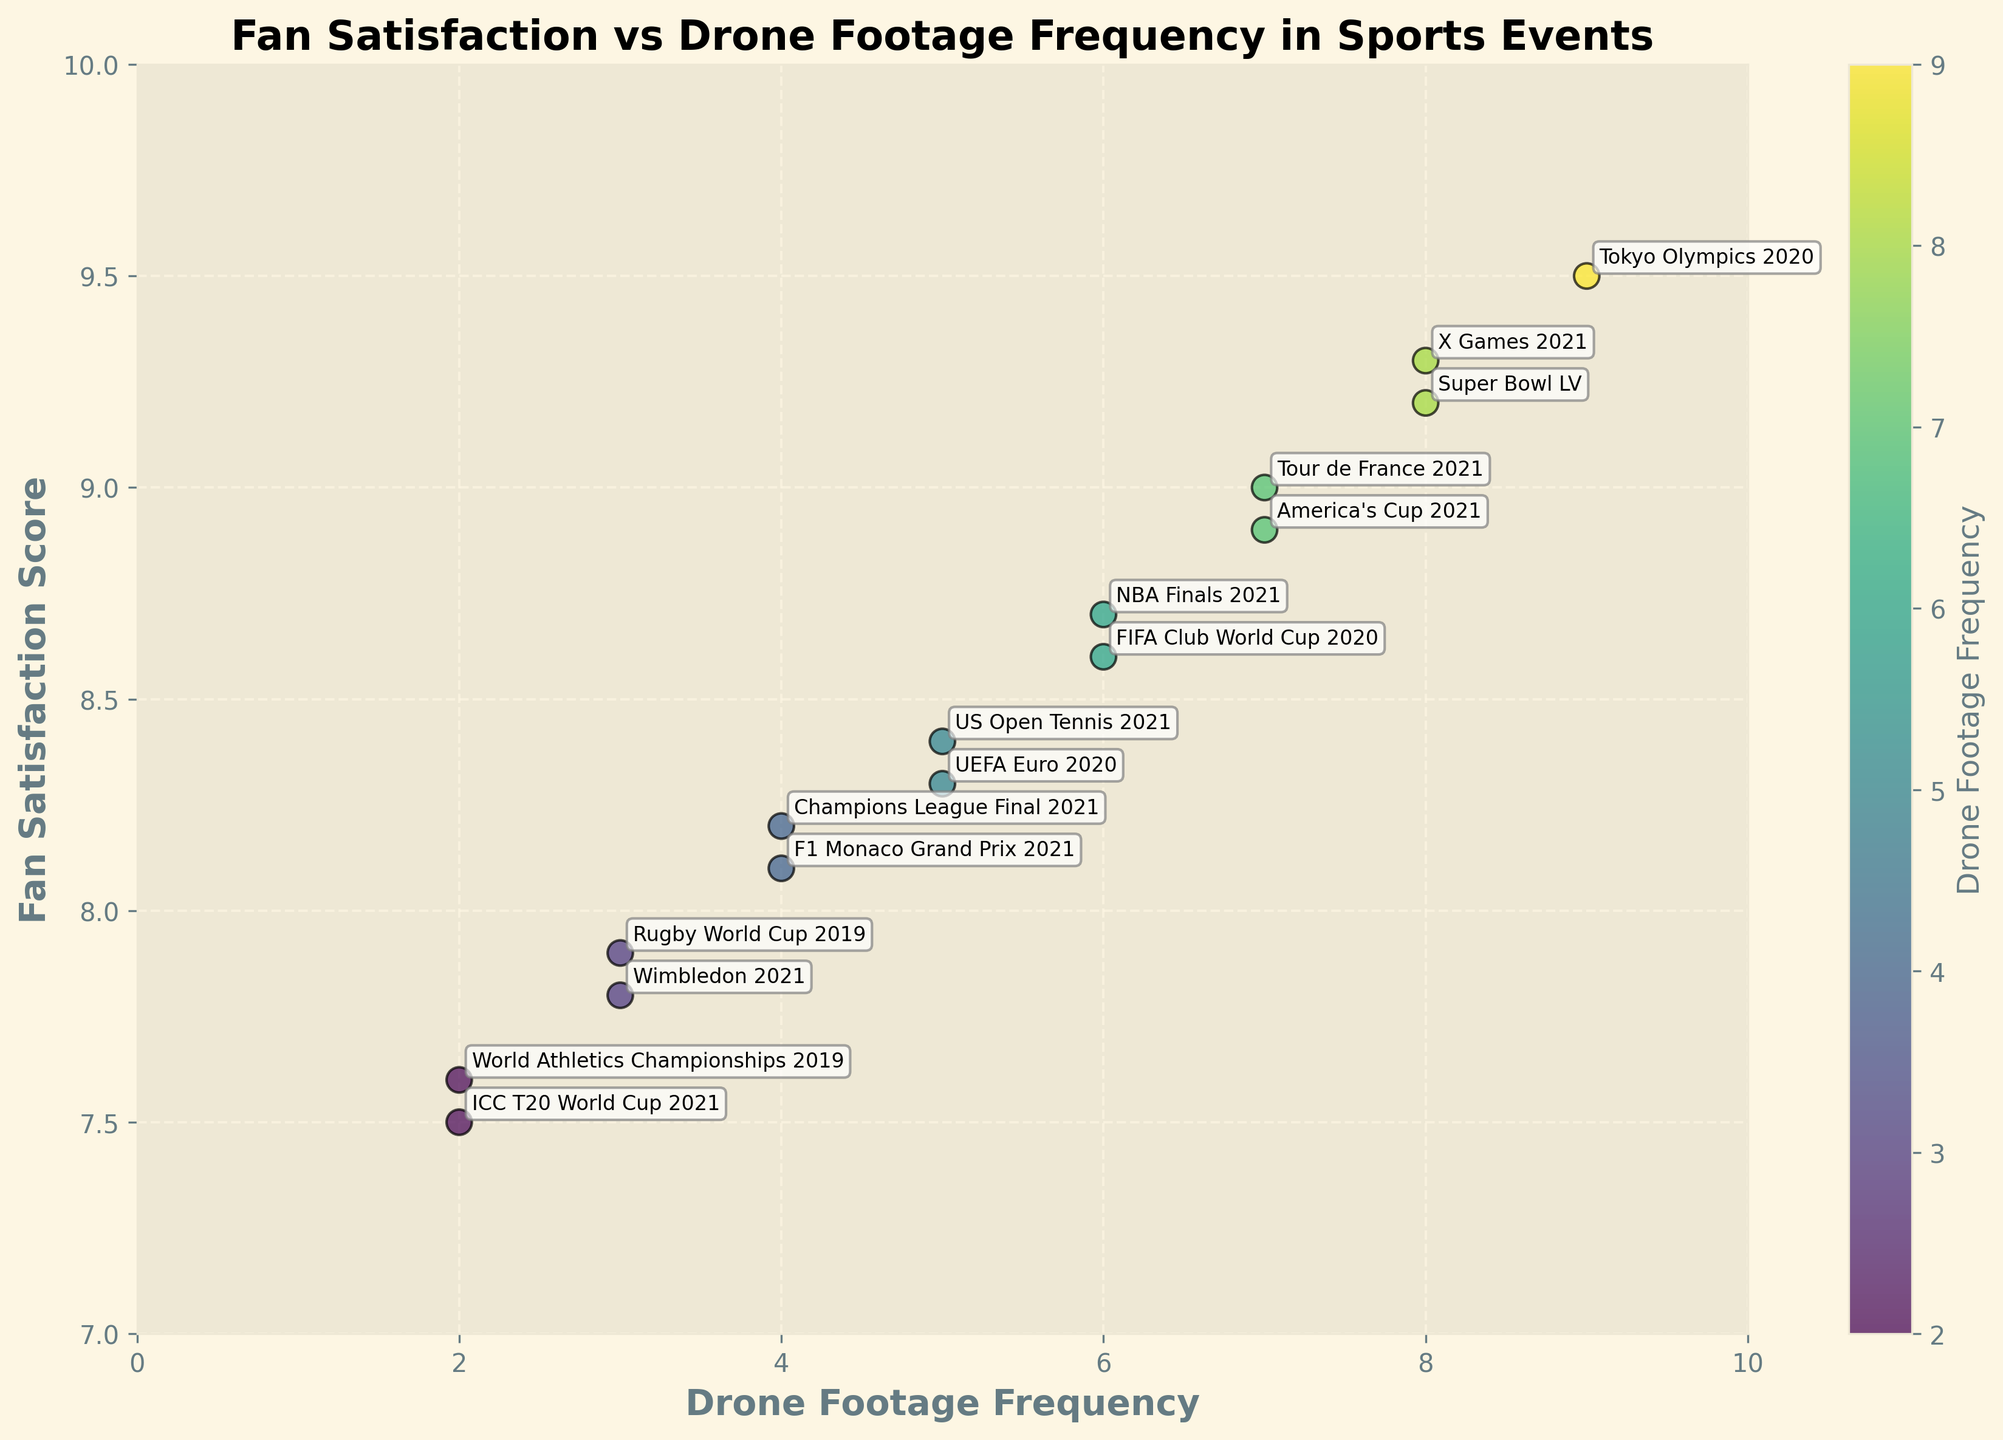What is the title of the figure? The title is typically located at the top of the figure. In this plot, the title indicates the relationship being analyzed.
Answer: Fan Satisfaction vs Drone Footage Frequency in Sports Events What are the x-axis and y-axis labels? The labels are written along the axes to represent what the data points signify. The x-axis shows "Drone Footage Frequency" while the y-axis shows "Fan Satisfaction Score".
Answer: Drone Footage Frequency and Fan Satisfaction Score How many events are plotted in the figure? Each data point represents an event, and there are annotations for each point. Counting these annotations gives us the total number of events.
Answer: 15 Which event has the highest fan satisfaction score? Look for the data point with the highest position on the y-axis and read the annotation next to it.
Answer: Tokyo Olympics 2020 Is there an instance where two events have the same frequency of drone footage integration? By observing the x-axis values, look for repeated values among the data points. There are two points at x = 6 and x = 4.
Answer: Yes What is the average fan satisfaction score for events with a drone footage frequency of 5? Identify all data points with x = 5, sum their y-values, and divide by the count. (8.3 + 8.4) / 2
Answer: 8.35 Which event has a higher fan satisfaction score, Wimbledon 2021 or America's Cup 2021? Compare the y-values of these two specific points on the plot.
Answer: America's Cup 2021 How many fan satisfaction scores are above 9.0? Count the number of data points that have y-values above 9.0.
Answer: 4 Which event has the lowest drone footage frequency, and what is its fan satisfaction score? Identify the point with the smallest x-value and read its corresponding y-value and annotation.
Answer: ICC T20 World Cup 2021, 7.5 Is there a general trend between drone footage frequency and fan satisfaction score? Observe the overall distribution of data points to identify any patterns or trends. Higher frequencies generally correspond to higher satisfaction.
Answer: Positive correlation 